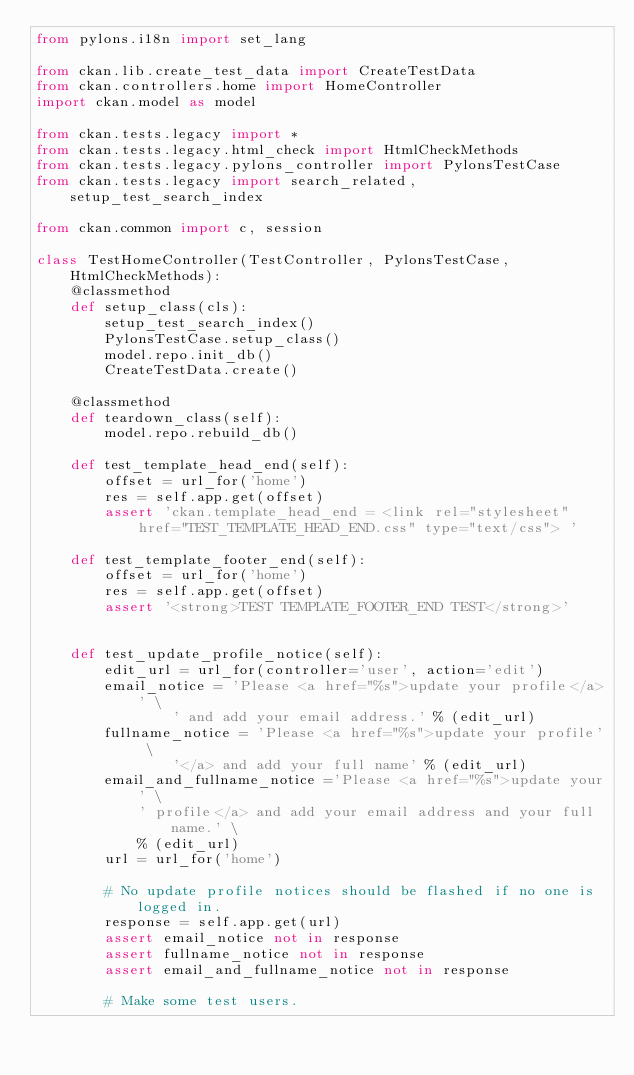<code> <loc_0><loc_0><loc_500><loc_500><_Python_>from pylons.i18n import set_lang

from ckan.lib.create_test_data import CreateTestData
from ckan.controllers.home import HomeController
import ckan.model as model

from ckan.tests.legacy import *
from ckan.tests.legacy.html_check import HtmlCheckMethods
from ckan.tests.legacy.pylons_controller import PylonsTestCase
from ckan.tests.legacy import search_related, setup_test_search_index

from ckan.common import c, session

class TestHomeController(TestController, PylonsTestCase, HtmlCheckMethods):
    @classmethod
    def setup_class(cls):
        setup_test_search_index()
        PylonsTestCase.setup_class()
        model.repo.init_db()
        CreateTestData.create()

    @classmethod
    def teardown_class(self):
        model.repo.rebuild_db()

    def test_template_head_end(self):
        offset = url_for('home')
        res = self.app.get(offset)
        assert 'ckan.template_head_end = <link rel="stylesheet" href="TEST_TEMPLATE_HEAD_END.css" type="text/css"> '

    def test_template_footer_end(self):
        offset = url_for('home')
        res = self.app.get(offset)
        assert '<strong>TEST TEMPLATE_FOOTER_END TEST</strong>'


    def test_update_profile_notice(self):
        edit_url = url_for(controller='user', action='edit')
        email_notice = 'Please <a href="%s">update your profile</a>' \
                ' and add your email address.' % (edit_url)
        fullname_notice = 'Please <a href="%s">update your profile' \
                '</a> and add your full name' % (edit_url)
        email_and_fullname_notice ='Please <a href="%s">update your' \
            ' profile</a> and add your email address and your full name.' \
            % (edit_url)
        url = url_for('home')

        # No update profile notices should be flashed if no one is logged in.
        response = self.app.get(url)
        assert email_notice not in response
        assert fullname_notice not in response
        assert email_and_fullname_notice not in response

        # Make some test users.</code> 